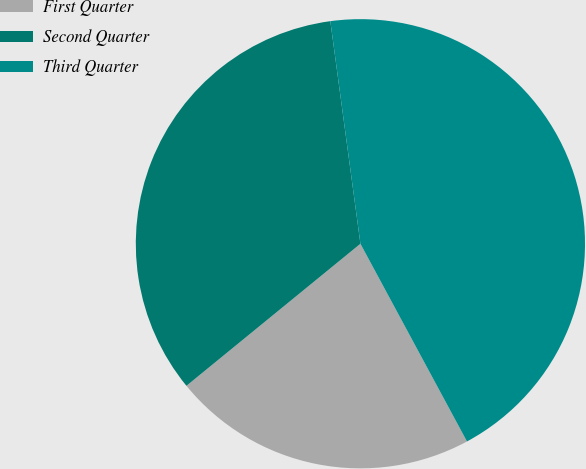<chart> <loc_0><loc_0><loc_500><loc_500><pie_chart><fcel>First Quarter<fcel>Second Quarter<fcel>Third Quarter<nl><fcel>21.97%<fcel>33.76%<fcel>44.27%<nl></chart> 